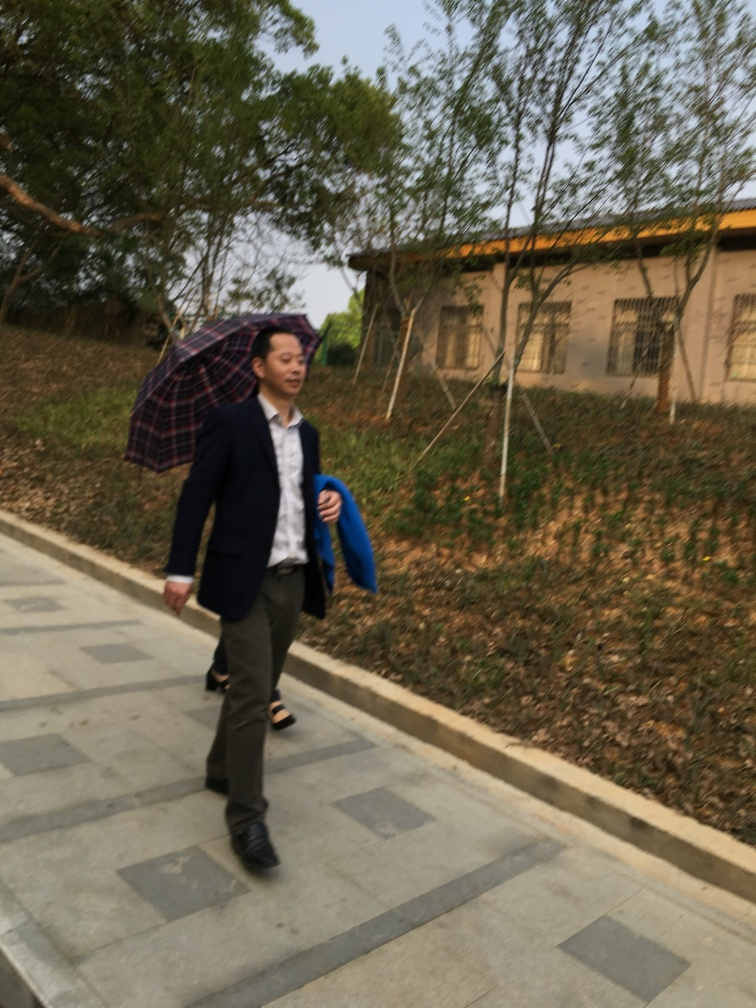What time of day does it seem to be in the image? The image lacks strong lighting, but the natural light suggests it could be morning or late afternoon. There's no indication of dusk or dawn hues in the sky, which would be typically more vibrant, thus it's more likely a cloudy day which can make it difficult to determine the precise time. 